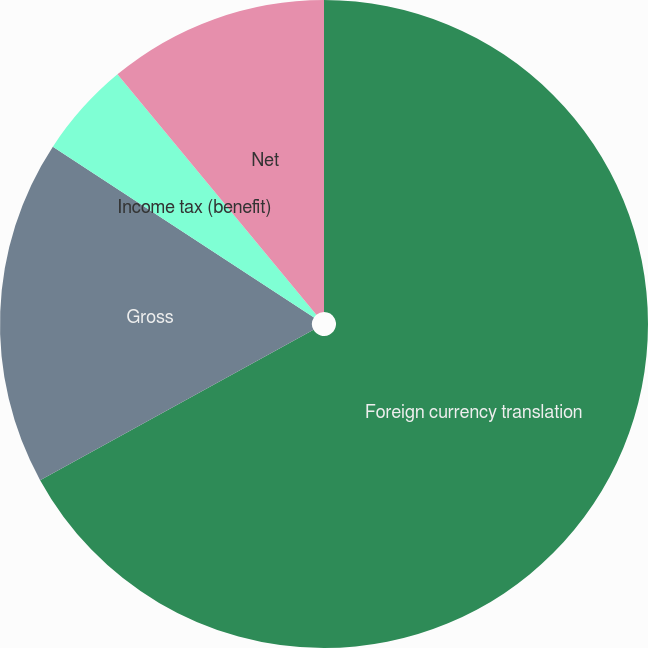<chart> <loc_0><loc_0><loc_500><loc_500><pie_chart><fcel>Foreign currency translation<fcel>Gross<fcel>Income tax (benefit)<fcel>Net<nl><fcel>66.99%<fcel>17.22%<fcel>4.78%<fcel>11.0%<nl></chart> 